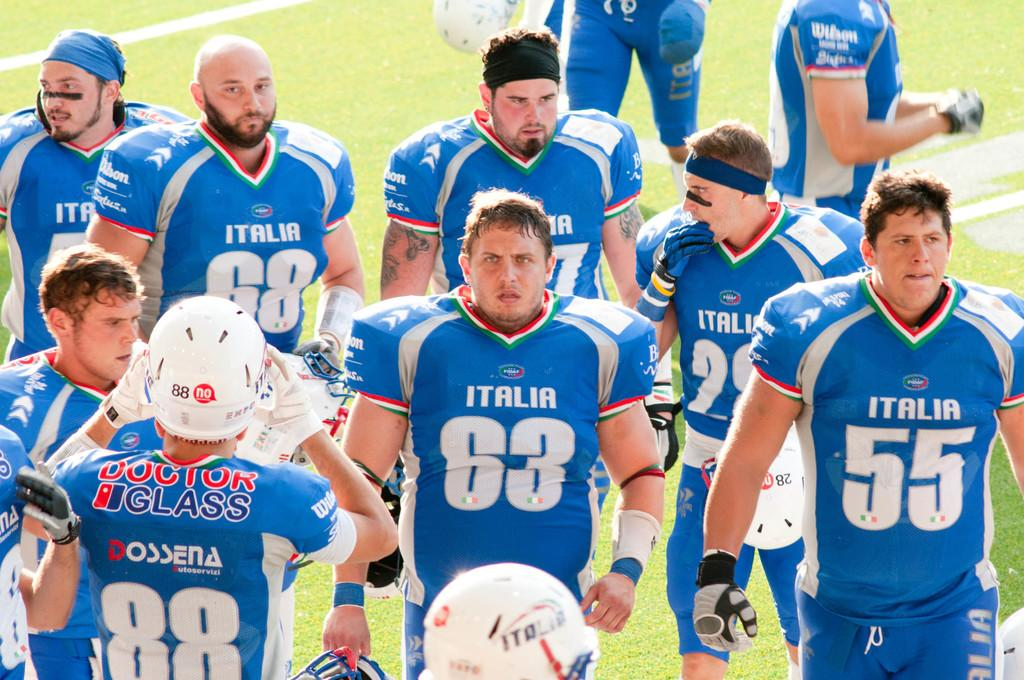<image>
Describe the image concisely. one of the players has the number 55 on their jersey 